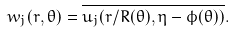Convert formula to latex. <formula><loc_0><loc_0><loc_500><loc_500>w _ { j } ( r , \theta ) = \overline { u _ { j } ( r / R ( \theta ) , \eta - \phi ( \theta ) ) } .</formula> 